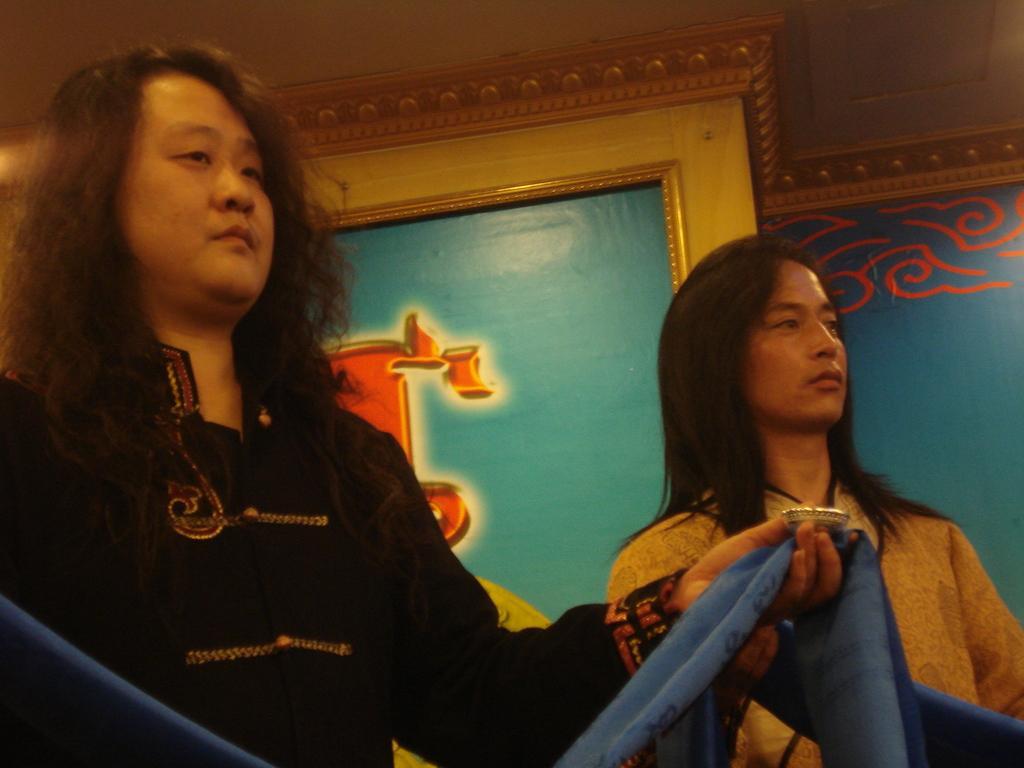Can you describe this image briefly? There are people standing and holding clothes. In the background we can see frame on a wall. 